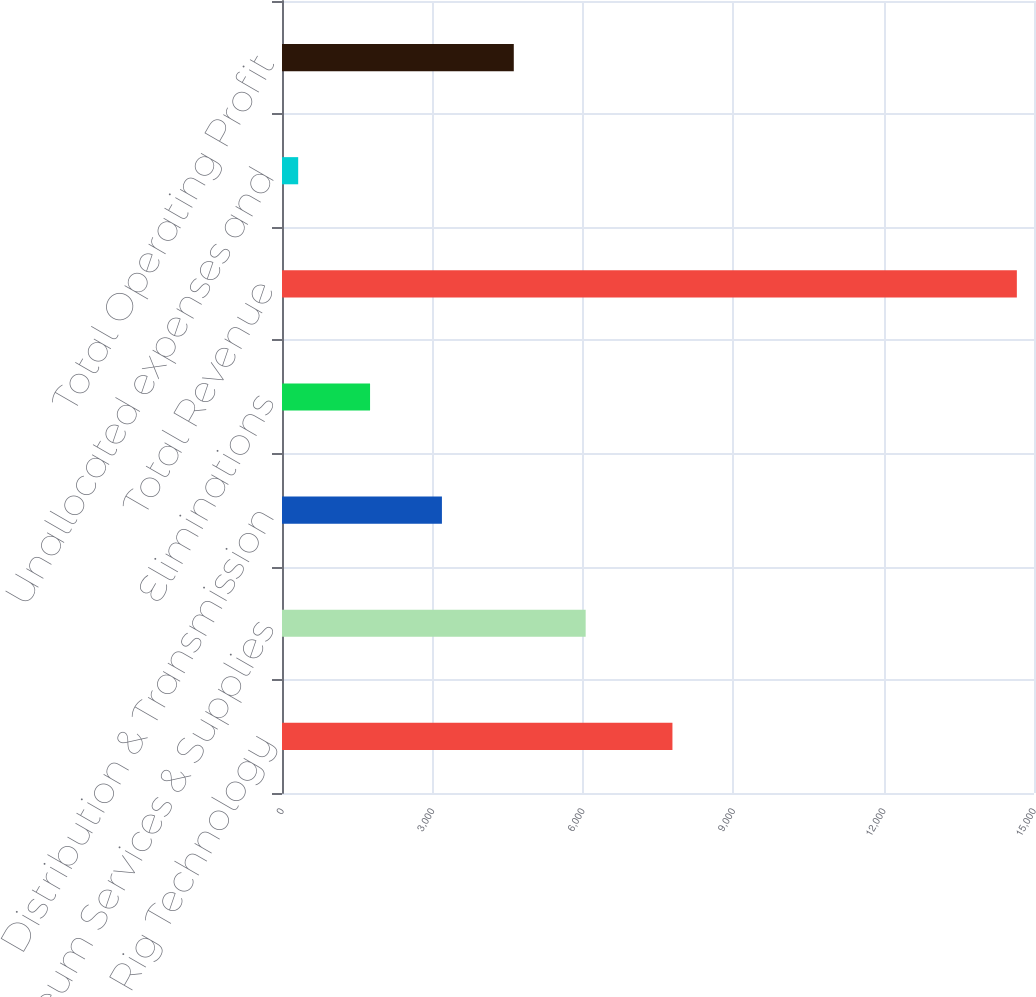Convert chart to OTSL. <chart><loc_0><loc_0><loc_500><loc_500><bar_chart><fcel>Rig Technology<fcel>Petroleum Services & Supplies<fcel>Distribution & Transmission<fcel>Eliminations<fcel>Total Revenue<fcel>Unallocated expenses and<fcel>Total Operating Profit<nl><fcel>7788<fcel>6057<fcel>3190<fcel>1756.5<fcel>14658<fcel>323<fcel>4623.5<nl></chart> 